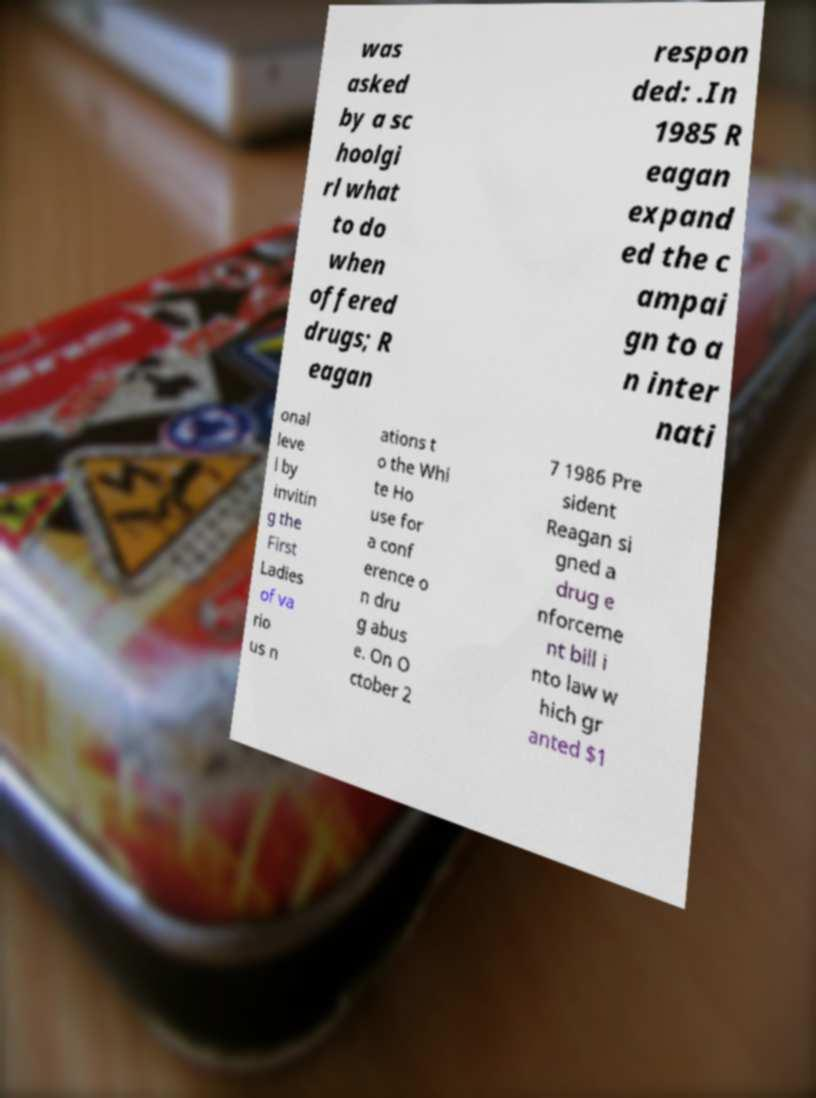Can you read and provide the text displayed in the image?This photo seems to have some interesting text. Can you extract and type it out for me? was asked by a sc hoolgi rl what to do when offered drugs; R eagan respon ded: .In 1985 R eagan expand ed the c ampai gn to a n inter nati onal leve l by invitin g the First Ladies of va rio us n ations t o the Whi te Ho use for a conf erence o n dru g abus e. On O ctober 2 7 1986 Pre sident Reagan si gned a drug e nforceme nt bill i nto law w hich gr anted $1 